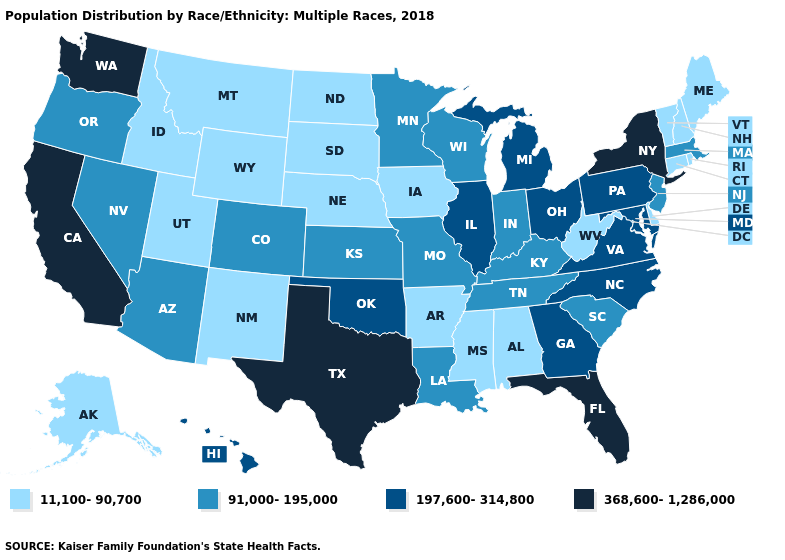Name the states that have a value in the range 11,100-90,700?
Quick response, please. Alabama, Alaska, Arkansas, Connecticut, Delaware, Idaho, Iowa, Maine, Mississippi, Montana, Nebraska, New Hampshire, New Mexico, North Dakota, Rhode Island, South Dakota, Utah, Vermont, West Virginia, Wyoming. Among the states that border Maine , which have the lowest value?
Short answer required. New Hampshire. Among the states that border New Jersey , does New York have the lowest value?
Give a very brief answer. No. Among the states that border Missouri , does Kansas have the highest value?
Quick response, please. No. Does Michigan have the highest value in the MidWest?
Write a very short answer. Yes. What is the lowest value in the West?
Be succinct. 11,100-90,700. Name the states that have a value in the range 91,000-195,000?
Quick response, please. Arizona, Colorado, Indiana, Kansas, Kentucky, Louisiana, Massachusetts, Minnesota, Missouri, Nevada, New Jersey, Oregon, South Carolina, Tennessee, Wisconsin. Name the states that have a value in the range 11,100-90,700?
Short answer required. Alabama, Alaska, Arkansas, Connecticut, Delaware, Idaho, Iowa, Maine, Mississippi, Montana, Nebraska, New Hampshire, New Mexico, North Dakota, Rhode Island, South Dakota, Utah, Vermont, West Virginia, Wyoming. What is the value of Alaska?
Be succinct. 11,100-90,700. How many symbols are there in the legend?
Keep it brief. 4. What is the lowest value in states that border South Carolina?
Answer briefly. 197,600-314,800. Does Maryland have the highest value in the USA?
Be succinct. No. Does Iowa have a higher value than Georgia?
Keep it brief. No. Among the states that border Nevada , which have the highest value?
Short answer required. California. How many symbols are there in the legend?
Write a very short answer. 4. 